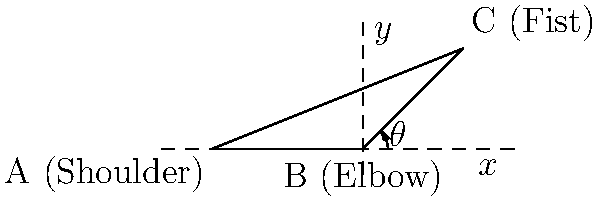In a boxing match, you're analyzing the optimal angle for a punch. The diagram shows the positions of your shoulder (A), elbow (B), and fist (C). Given that AB = 3 units, BC = 2.83 units, and the vertical distance from B to C is 2 units, calculate the angle $\theta$ (in degrees) at the elbow for the most effective punch. Round your answer to the nearest degree. To find the angle $\theta$, we'll use trigonometry:

1) First, let's identify the right triangle formed by the elbow (B), fist (C), and the vertical line from B to the x-axis.

2) We know the vertical distance (opposite side) is 2 units.

3) We need to find the horizontal distance (adjacent side):
   - The total horizontal distance from A to C is 5 units (given by the x-coordinate of C)
   - The distance from A to B is 3 units
   - So, the horizontal distance from B to C is 5 - 3 = 2 units

4) Now we have a right triangle with:
   - Opposite side = 2 units
   - Adjacent side = 2 units

5) To find $\theta$, we use the arctangent function:

   $$\theta = \arctan(\frac{\text{opposite}}{\text{adjacent}}) = \arctan(\frac{2}{2}) = \arctan(1)$$

6) $\arctan(1)$ is equal to 45°

Therefore, the optimal angle $\theta$ for the most effective punch is 45°.
Answer: 45° 